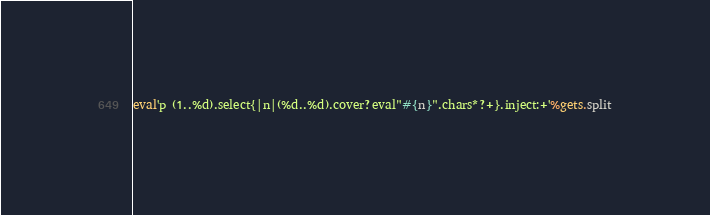<code> <loc_0><loc_0><loc_500><loc_500><_Ruby_>eval'p (1..%d).select{|n|(%d..%d).cover?eval"#{n}".chars*?+}.inject:+'%gets.split</code> 